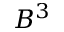Convert formula to latex. <formula><loc_0><loc_0><loc_500><loc_500>B ^ { 3 }</formula> 